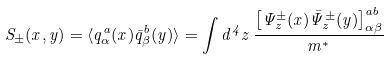<formula> <loc_0><loc_0><loc_500><loc_500>S _ { \pm } ( x , y ) = \langle q _ { \alpha } ^ { a } ( x ) { \bar { q } } _ { \beta } ^ { b } ( y ) \rangle = \int d ^ { 4 } z \, \frac { \left [ \Psi _ { z } ^ { \pm } ( x ) { \bar { \Psi } } _ { z } ^ { \pm } ( y ) \right ] _ { \alpha \beta } ^ { a b } } { m ^ { * } }</formula> 